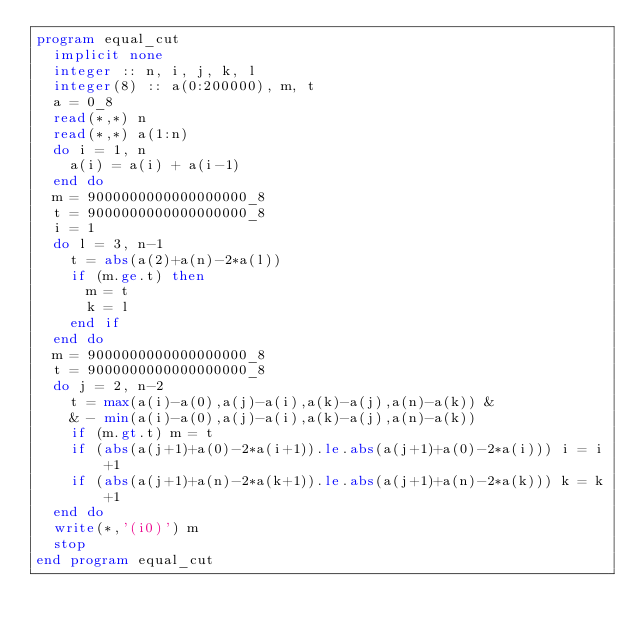Convert code to text. <code><loc_0><loc_0><loc_500><loc_500><_FORTRAN_>program equal_cut
  implicit none
  integer :: n, i, j, k, l
  integer(8) :: a(0:200000), m, t
  a = 0_8
  read(*,*) n
  read(*,*) a(1:n)
  do i = 1, n
    a(i) = a(i) + a(i-1)
  end do
  m = 9000000000000000000_8
  t = 9000000000000000000_8
  i = 1
  do l = 3, n-1
    t = abs(a(2)+a(n)-2*a(l))
    if (m.ge.t) then
      m = t
      k = l
    end if
  end do
  m = 9000000000000000000_8
  t = 9000000000000000000_8
  do j = 2, n-2
    t = max(a(i)-a(0),a(j)-a(i),a(k)-a(j),a(n)-a(k)) &
    & - min(a(i)-a(0),a(j)-a(i),a(k)-a(j),a(n)-a(k))
    if (m.gt.t) m = t
    if (abs(a(j+1)+a(0)-2*a(i+1)).le.abs(a(j+1)+a(0)-2*a(i))) i = i+1
    if (abs(a(j+1)+a(n)-2*a(k+1)).le.abs(a(j+1)+a(n)-2*a(k))) k = k+1
  end do
  write(*,'(i0)') m
  stop
end program equal_cut</code> 